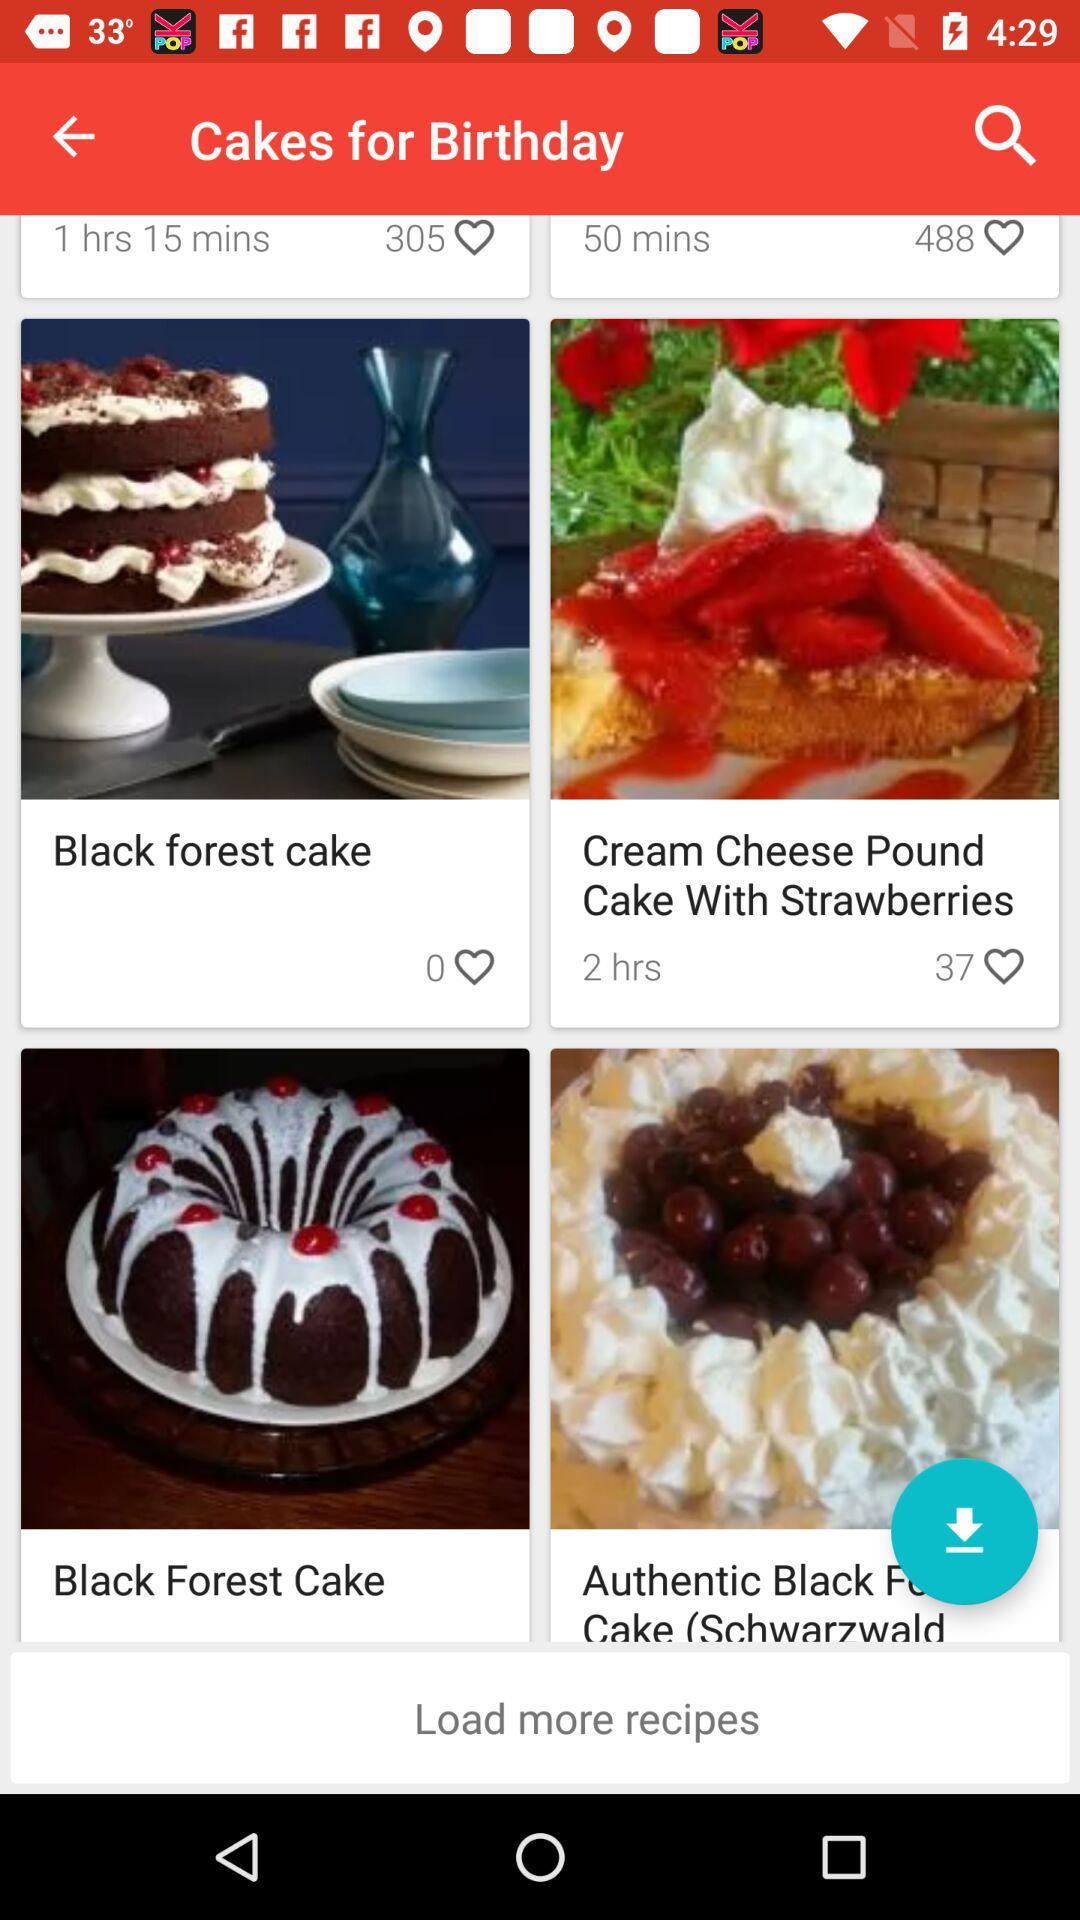Which types of cakes are available? The types of cakes available are "Black forest cake" and "Cream Cheese Pound Cake With Strawberries". 